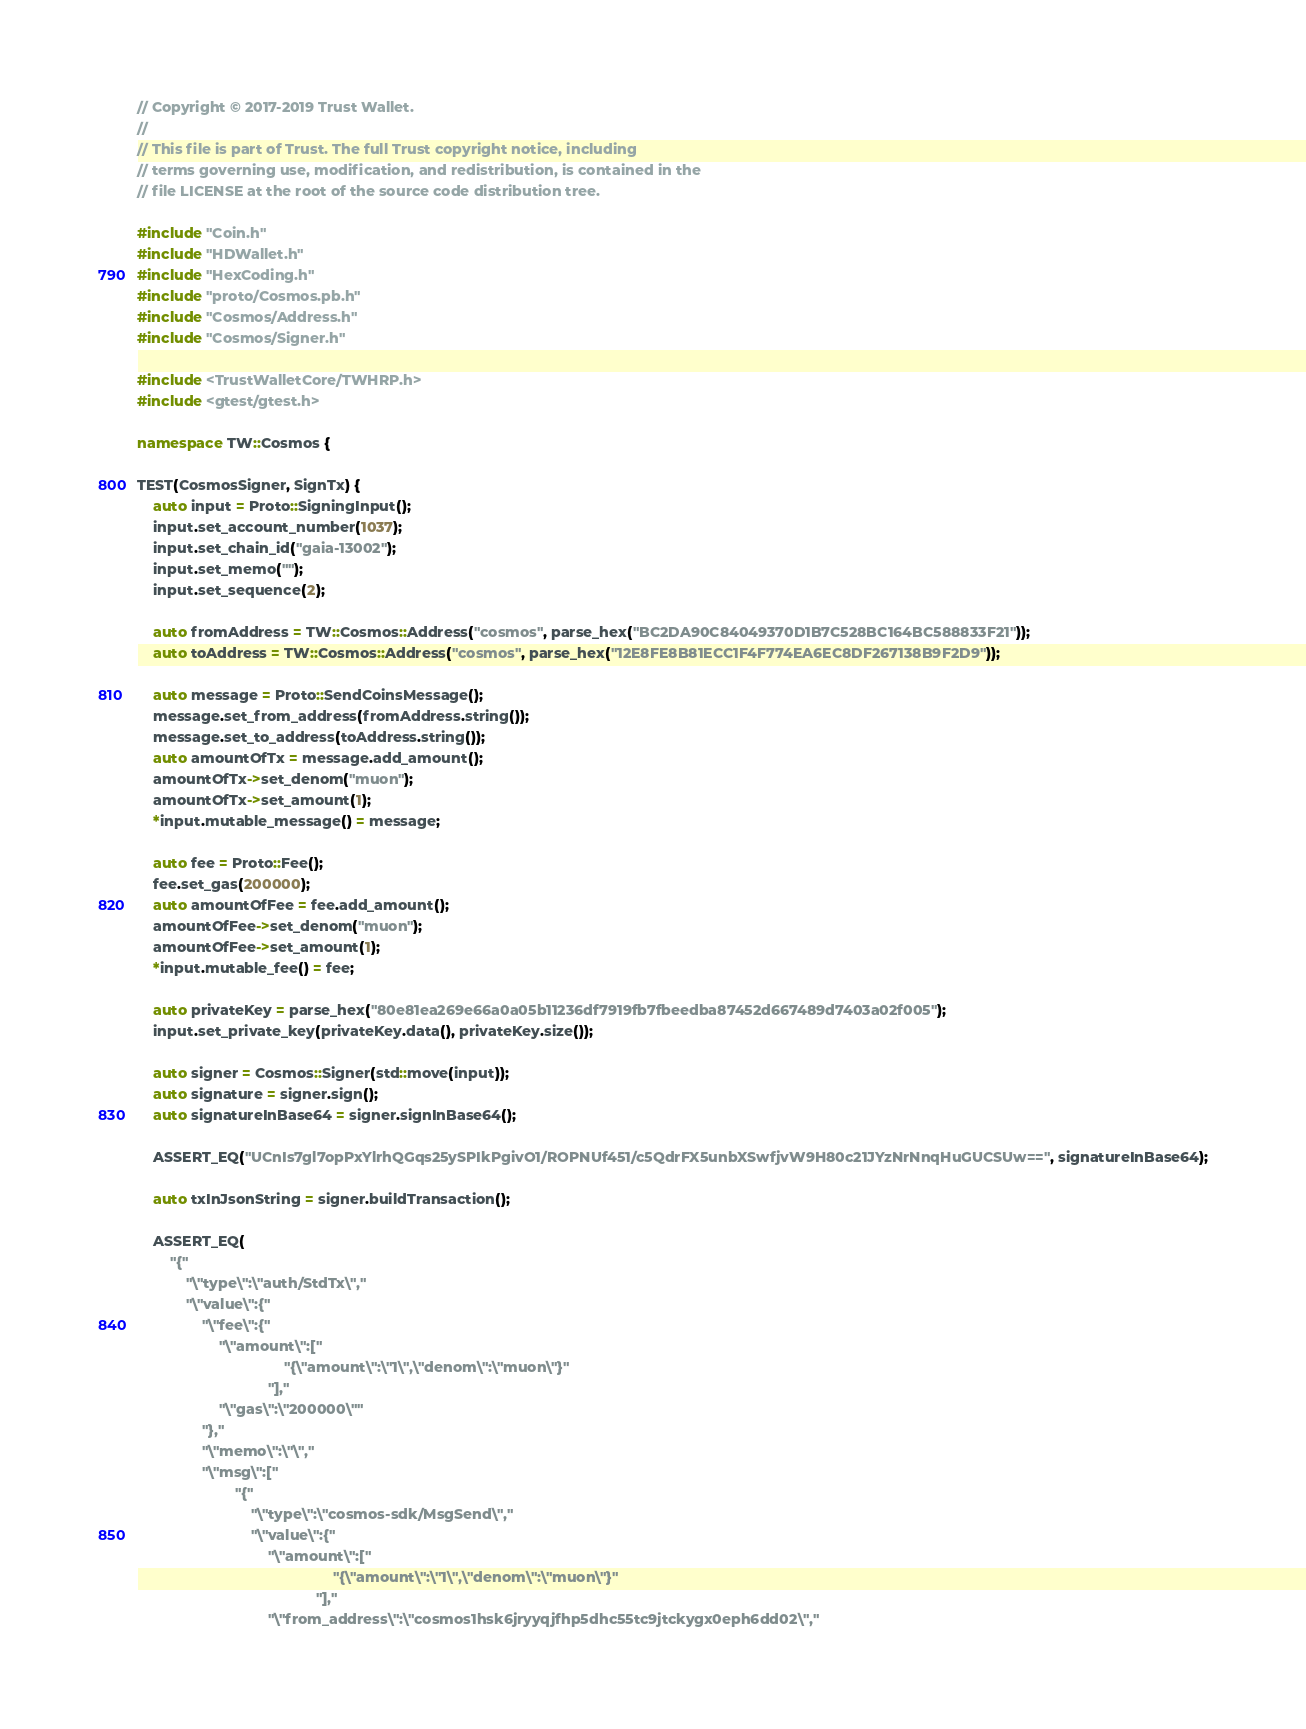<code> <loc_0><loc_0><loc_500><loc_500><_C++_>// Copyright © 2017-2019 Trust Wallet.
//
// This file is part of Trust. The full Trust copyright notice, including
// terms governing use, modification, and redistribution, is contained in the
// file LICENSE at the root of the source code distribution tree.

#include "Coin.h"
#include "HDWallet.h"
#include "HexCoding.h"
#include "proto/Cosmos.pb.h"
#include "Cosmos/Address.h"
#include "Cosmos/Signer.h"

#include <TrustWalletCore/TWHRP.h>
#include <gtest/gtest.h>

namespace TW::Cosmos {

TEST(CosmosSigner, SignTx) {
    auto input = Proto::SigningInput();
    input.set_account_number(1037);
    input.set_chain_id("gaia-13002");
    input.set_memo("");
    input.set_sequence(2);

    auto fromAddress = TW::Cosmos::Address("cosmos", parse_hex("BC2DA90C84049370D1B7C528BC164BC588833F21"));
    auto toAddress = TW::Cosmos::Address("cosmos", parse_hex("12E8FE8B81ECC1F4F774EA6EC8DF267138B9F2D9"));

    auto message = Proto::SendCoinsMessage();
    message.set_from_address(fromAddress.string());
    message.set_to_address(toAddress.string());
    auto amountOfTx = message.add_amount();
    amountOfTx->set_denom("muon");
    amountOfTx->set_amount(1);
    *input.mutable_message() = message;
    
    auto fee = Proto::Fee();
    fee.set_gas(200000);
    auto amountOfFee = fee.add_amount();
    amountOfFee->set_denom("muon");
    amountOfFee->set_amount(1);
    *input.mutable_fee() = fee;

    auto privateKey = parse_hex("80e81ea269e66a0a05b11236df7919fb7fbeedba87452d667489d7403a02f005");
    input.set_private_key(privateKey.data(), privateKey.size());

    auto signer = Cosmos::Signer(std::move(input));
    auto signature = signer.sign();
    auto signatureInBase64 = signer.signInBase64();

    ASSERT_EQ("UCnIs7gl7opPxYlrhQGqs25ySPIkPgivO1/ROPNUf451/c5QdrFX5unbXSwfjvW9H80c21JYzNrNnqHuGUCSUw==", signatureInBase64);

    auto txInJsonString = signer.buildTransaction();

    ASSERT_EQ(
        "{"
            "\"type\":\"auth/StdTx\","
            "\"value\":{"
                "\"fee\":{"
                    "\"amount\":["
                                    "{\"amount\":\"1\",\"denom\":\"muon\"}"
                                "],"
                    "\"gas\":\"200000\""
                "},"
                "\"memo\":\"\","
                "\"msg\":["
                        "{"
                            "\"type\":\"cosmos-sdk/MsgSend\","
                            "\"value\":{"
                                "\"amount\":["
                                                "{\"amount\":\"1\",\"denom\":\"muon\"}"
                                            "],"
                                "\"from_address\":\"cosmos1hsk6jryyqjfhp5dhc55tc9jtckygx0eph6dd02\","</code> 